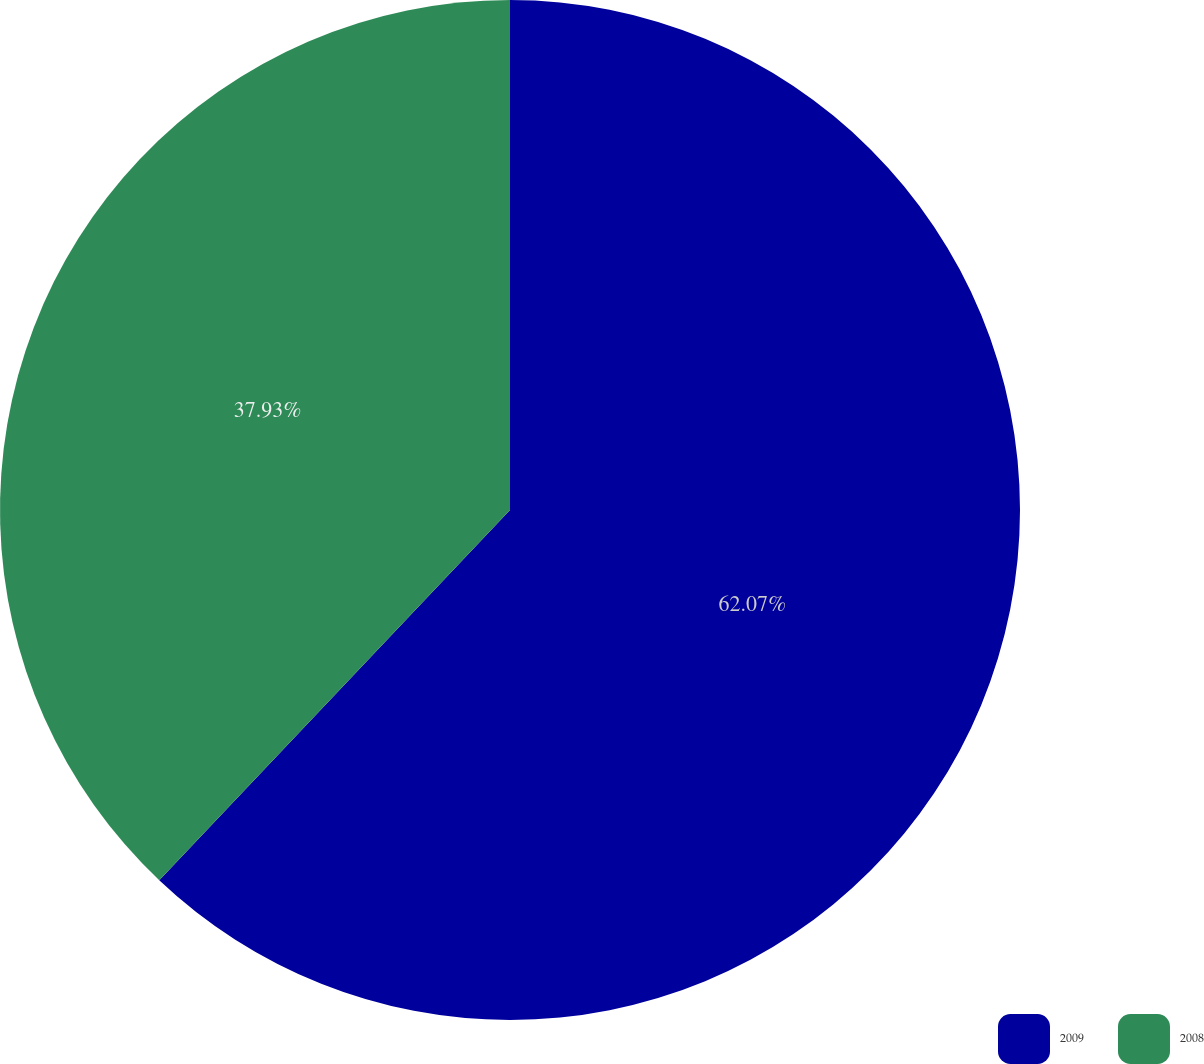<chart> <loc_0><loc_0><loc_500><loc_500><pie_chart><fcel>2009<fcel>2008<nl><fcel>62.07%<fcel>37.93%<nl></chart> 